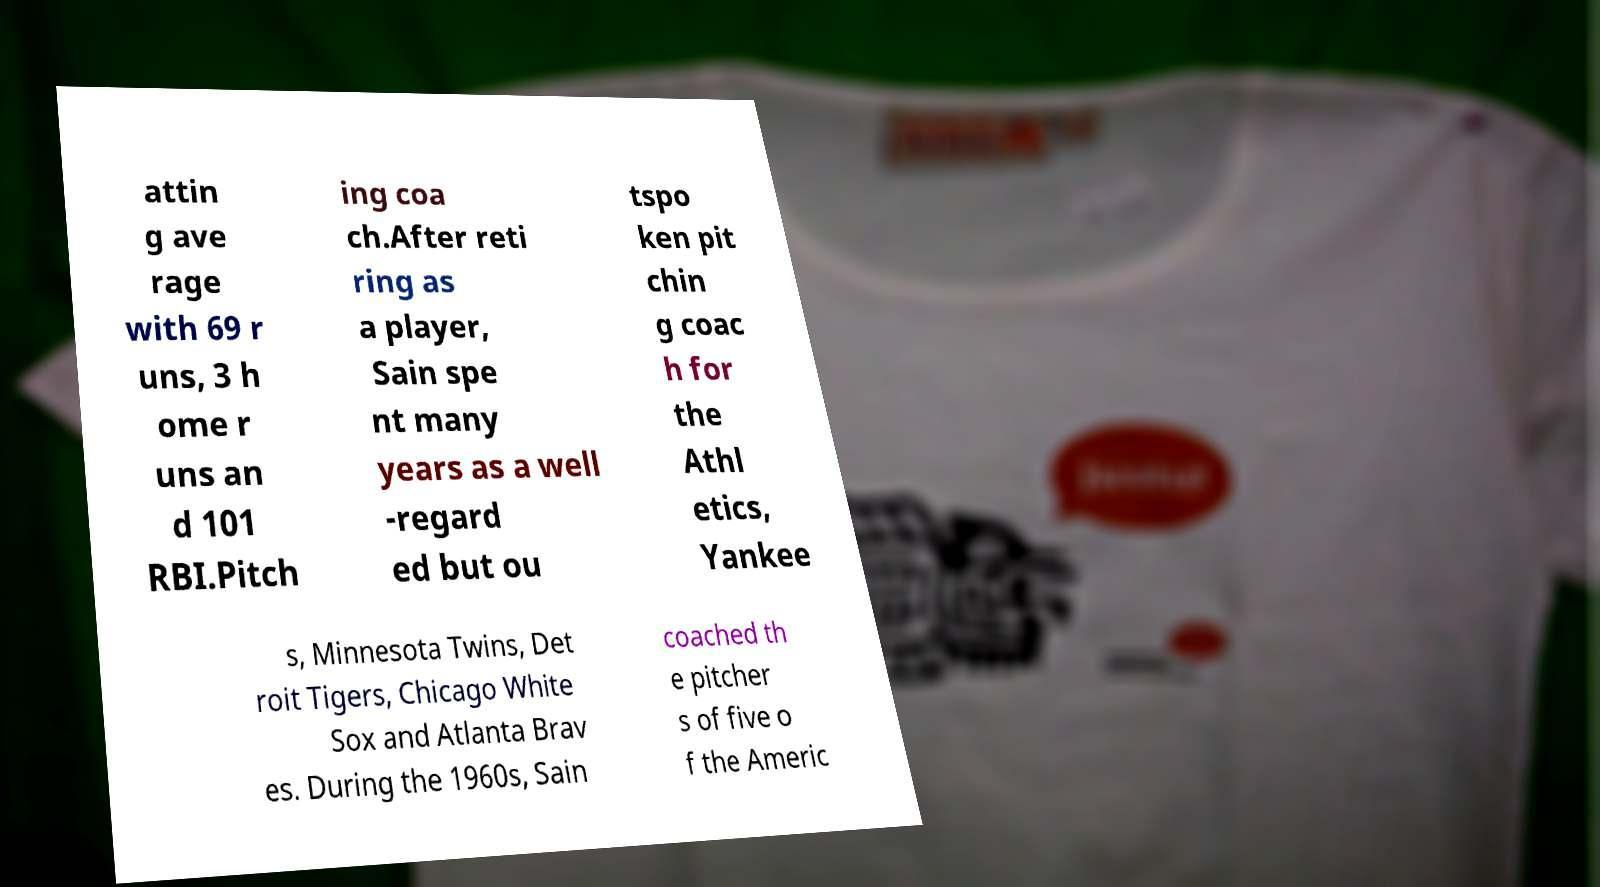I need the written content from this picture converted into text. Can you do that? attin g ave rage with 69 r uns, 3 h ome r uns an d 101 RBI.Pitch ing coa ch.After reti ring as a player, Sain spe nt many years as a well -regard ed but ou tspo ken pit chin g coac h for the Athl etics, Yankee s, Minnesota Twins, Det roit Tigers, Chicago White Sox and Atlanta Brav es. During the 1960s, Sain coached th e pitcher s of five o f the Americ 